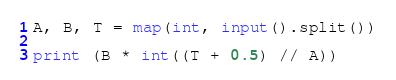Convert code to text. <code><loc_0><loc_0><loc_500><loc_500><_Python_>A, B, T = map(int, input().split())

print (B * int((T + 0.5) // A))
</code> 